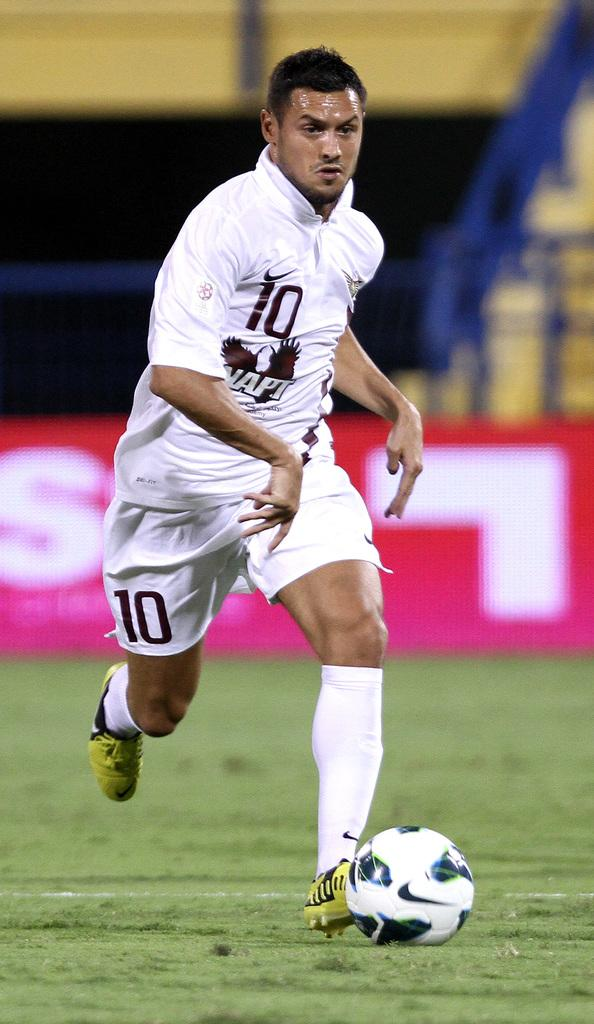<image>
Present a compact description of the photo's key features. a player that has the number 10 on their shirt 